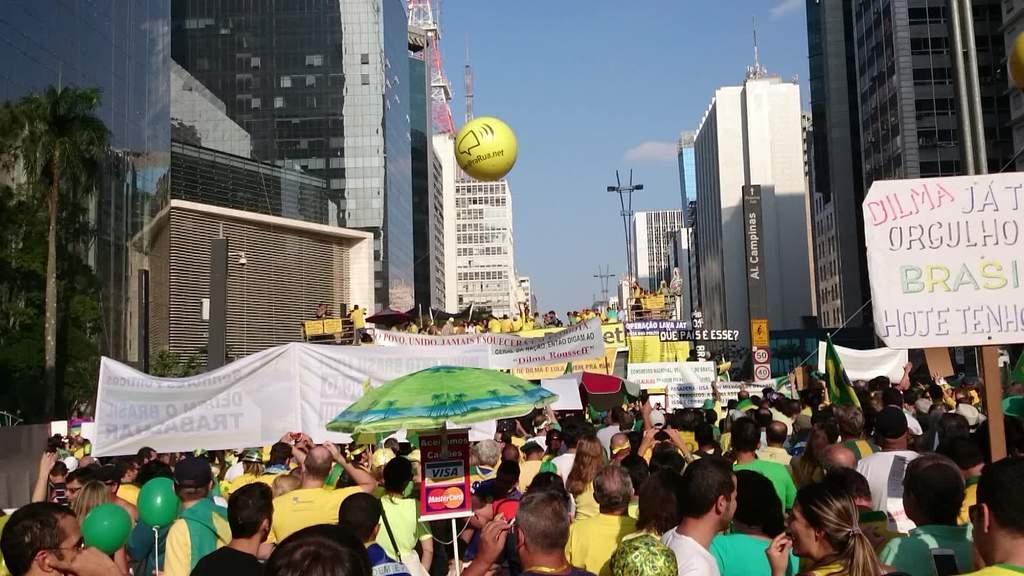In one or two sentences, can you explain what this image depicts? This image consists of many persons walking in the street. They are holding banners and placards. To the left and right, there are buildings. At the top, there are clouds in the sky. 